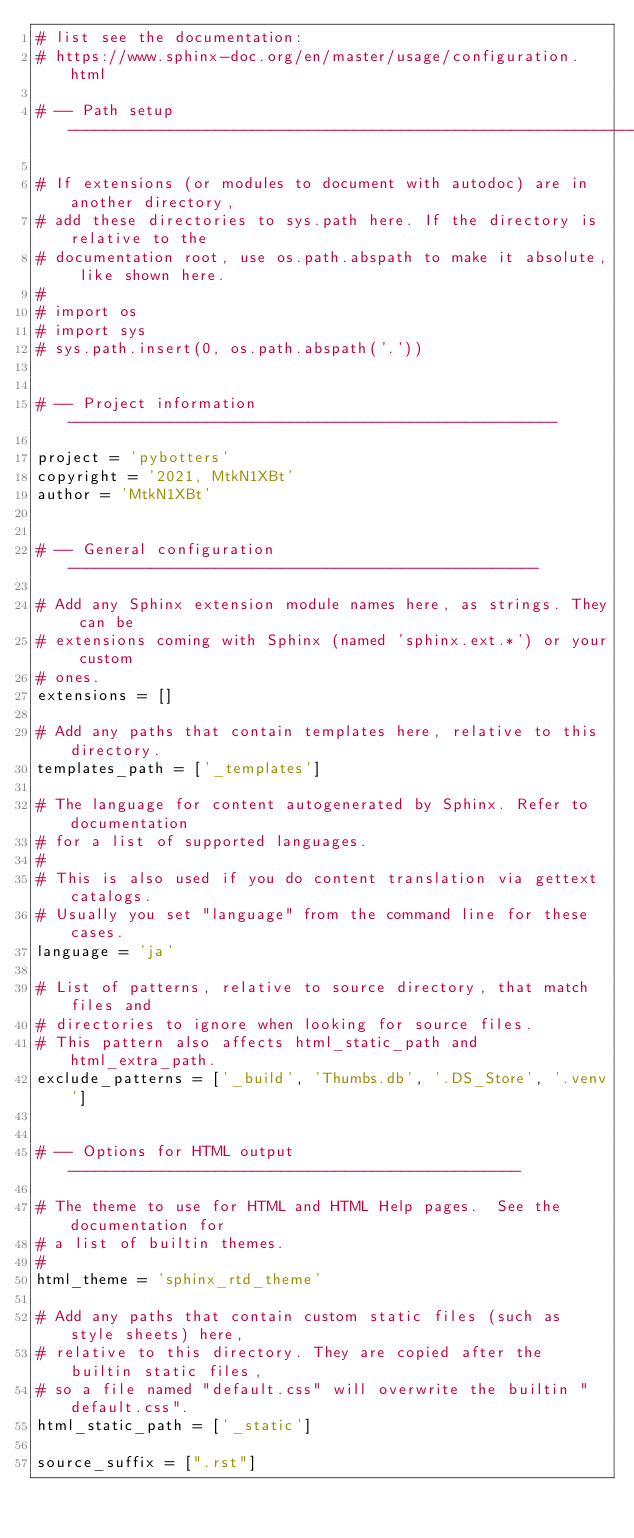<code> <loc_0><loc_0><loc_500><loc_500><_Python_># list see the documentation:
# https://www.sphinx-doc.org/en/master/usage/configuration.html

# -- Path setup --------------------------------------------------------------

# If extensions (or modules to document with autodoc) are in another directory,
# add these directories to sys.path here. If the directory is relative to the
# documentation root, use os.path.abspath to make it absolute, like shown here.
#
# import os
# import sys
# sys.path.insert(0, os.path.abspath('.'))


# -- Project information -----------------------------------------------------

project = 'pybotters'
copyright = '2021, MtkN1XBt'
author = 'MtkN1XBt'


# -- General configuration ---------------------------------------------------

# Add any Sphinx extension module names here, as strings. They can be
# extensions coming with Sphinx (named 'sphinx.ext.*') or your custom
# ones.
extensions = []

# Add any paths that contain templates here, relative to this directory.
templates_path = ['_templates']

# The language for content autogenerated by Sphinx. Refer to documentation
# for a list of supported languages.
#
# This is also used if you do content translation via gettext catalogs.
# Usually you set "language" from the command line for these cases.
language = 'ja'

# List of patterns, relative to source directory, that match files and
# directories to ignore when looking for source files.
# This pattern also affects html_static_path and html_extra_path.
exclude_patterns = ['_build', 'Thumbs.db', '.DS_Store', '.venv']


# -- Options for HTML output -------------------------------------------------

# The theme to use for HTML and HTML Help pages.  See the documentation for
# a list of builtin themes.
#
html_theme = 'sphinx_rtd_theme'

# Add any paths that contain custom static files (such as style sheets) here,
# relative to this directory. They are copied after the builtin static files,
# so a file named "default.css" will overwrite the builtin "default.css".
html_static_path = ['_static']

source_suffix = [".rst"]
</code> 